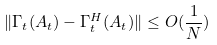<formula> <loc_0><loc_0><loc_500><loc_500>\| \Gamma _ { t } ( A _ { t } ) - \Gamma _ { t } ^ { H } ( A _ { t } ) \| \leq O ( \frac { 1 } { N } )</formula> 